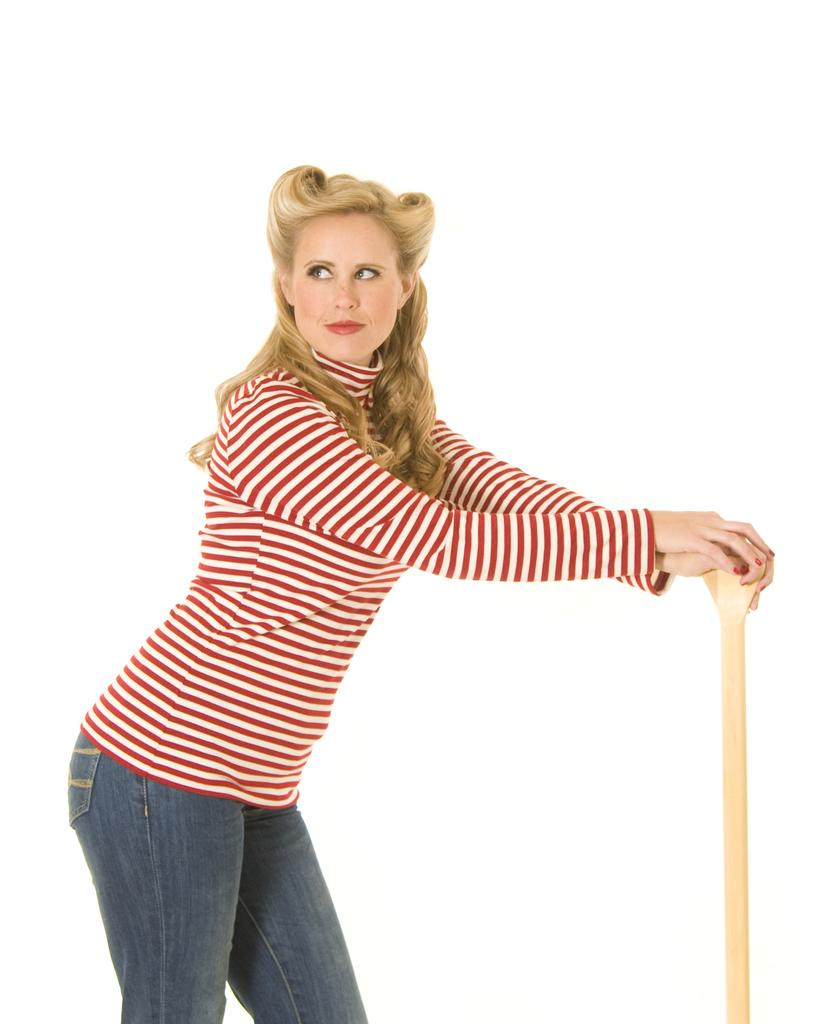Who is the main subject in the image? There is a woman in the picture. Where is the woman located in the image? The woman is in the middle of the image. What type of clothing is the woman wearing? The woman is wearing a t-shirt and trousers. What is the woman holding in the image? The woman is holding an object. What type of boats can be seen in the image? There are no boats present in the image; it features a woman in the middle of the image. What shape does the woman's control panel have in the image? There is no control panel or any indication of one in the image. 